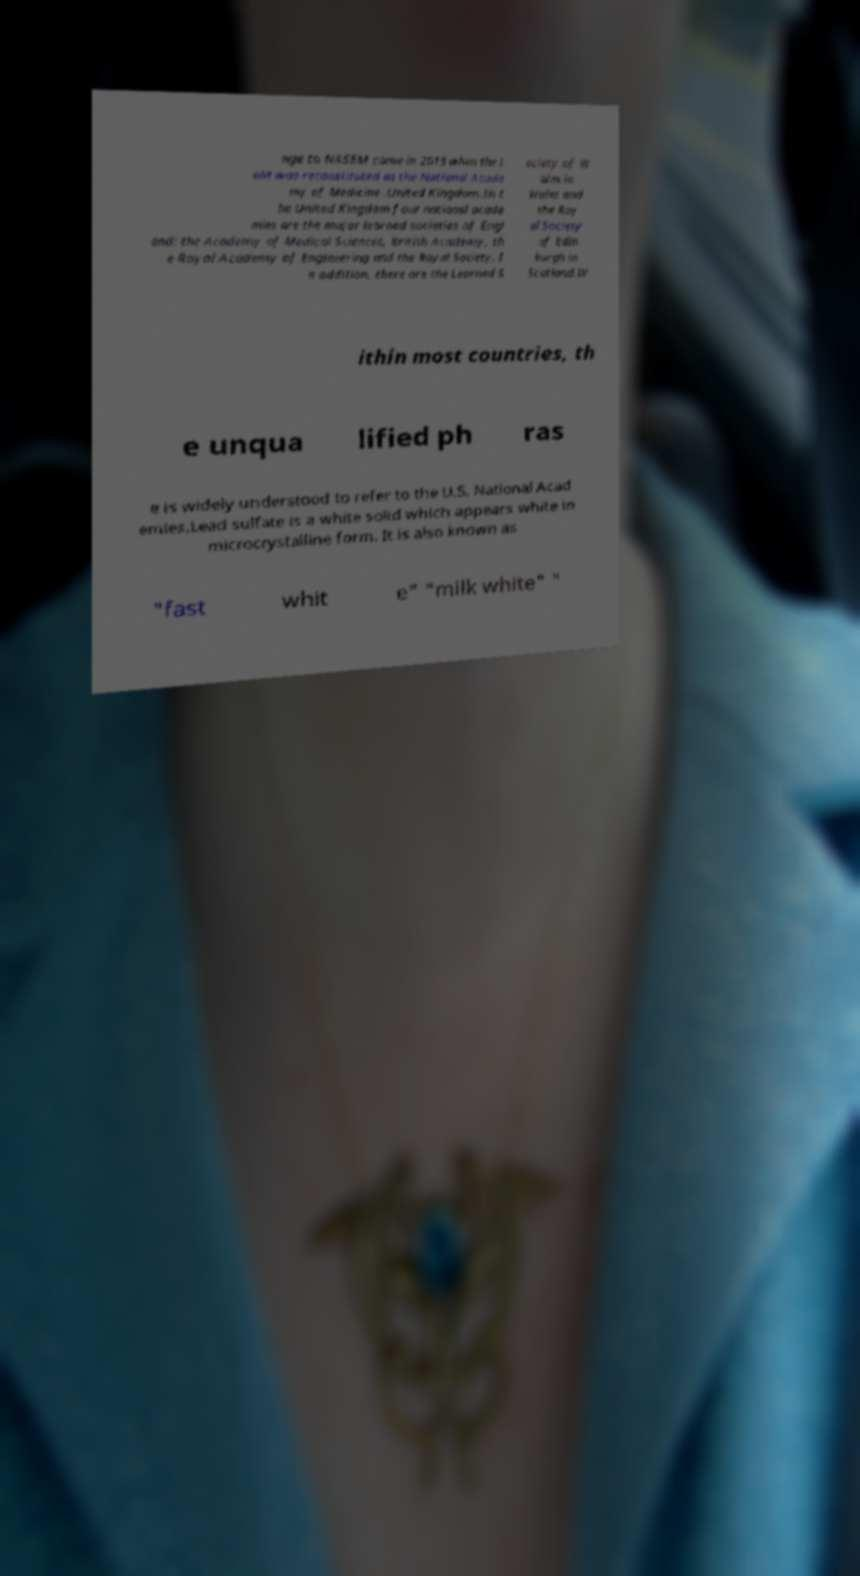What messages or text are displayed in this image? I need them in a readable, typed format. nge to NASEM came in 2015 when the I oM was reconstituted as the National Acade my of Medicine .United Kingdom.In t he United Kingdom four national acade mies are the major learned societies of Engl and: the Academy of Medical Sciences, British Academy, th e Royal Academy of Engineering and the Royal Society. I n addition, there are the Learned S ociety of W ales in Wales and the Roy al Society of Edin burgh in Scotland.W ithin most countries, th e unqua lified ph ras e is widely understood to refer to the U.S. National Acad emies.Lead sulfate is a white solid which appears white in microcrystalline form. It is also known as "fast whit e" "milk white" " 